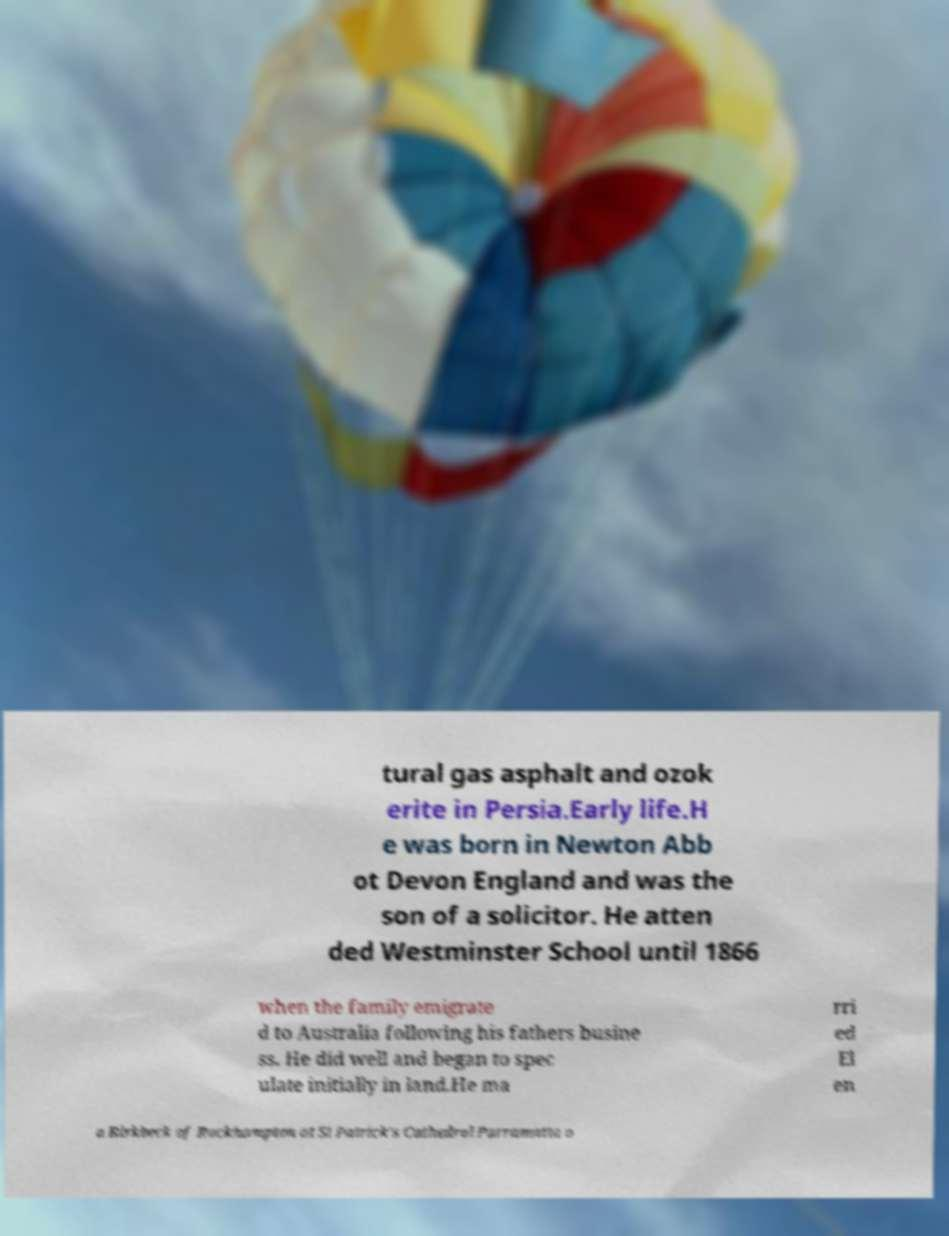Please read and relay the text visible in this image. What does it say? tural gas asphalt and ozok erite in Persia.Early life.H e was born in Newton Abb ot Devon England and was the son of a solicitor. He atten ded Westminster School until 1866 when the family emigrate d to Australia following his fathers busine ss. He did well and began to spec ulate initially in land.He ma rri ed El en a Birkbeck of Rockhampton at St Patrick's Cathedral Parramatta o 